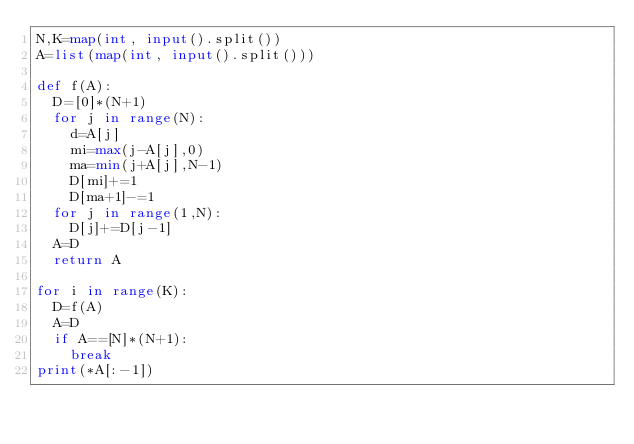<code> <loc_0><loc_0><loc_500><loc_500><_Python_>N,K=map(int, input().split())
A=list(map(int, input().split()))

def f(A):
  D=[0]*(N+1)
  for j in range(N):
    d=A[j]
    mi=max(j-A[j],0)
    ma=min(j+A[j],N-1)
    D[mi]+=1
    D[ma+1]-=1   
  for j in range(1,N):
    D[j]+=D[j-1]
  A=D
  return A 

for i in range(K):
  D=f(A)
  A=D
  if A==[N]*(N+1):
    break
print(*A[:-1])</code> 